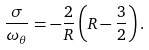<formula> <loc_0><loc_0><loc_500><loc_500>\frac { \sigma } { \omega _ { \theta } } = - \frac { 2 } { R } \left ( R - \frac { 3 } { 2 } \right ) .</formula> 